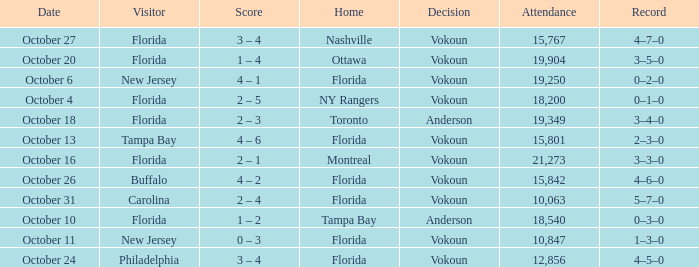What was the score on October 13? 4 – 6. 